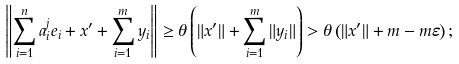Convert formula to latex. <formula><loc_0><loc_0><loc_500><loc_500>\left \| \sum _ { i = 1 } ^ { n } a ^ { j } _ { i } e _ { i } + x ^ { \prime } + \sum _ { i = 1 } ^ { m } y _ { i } \right \| \geq \theta \left ( \| x ^ { \prime } \| + \sum _ { i = 1 } ^ { m } \| y _ { i } \| \right ) > \theta \left ( \| x ^ { \prime } \| + m - m \varepsilon \right ) ;</formula> 